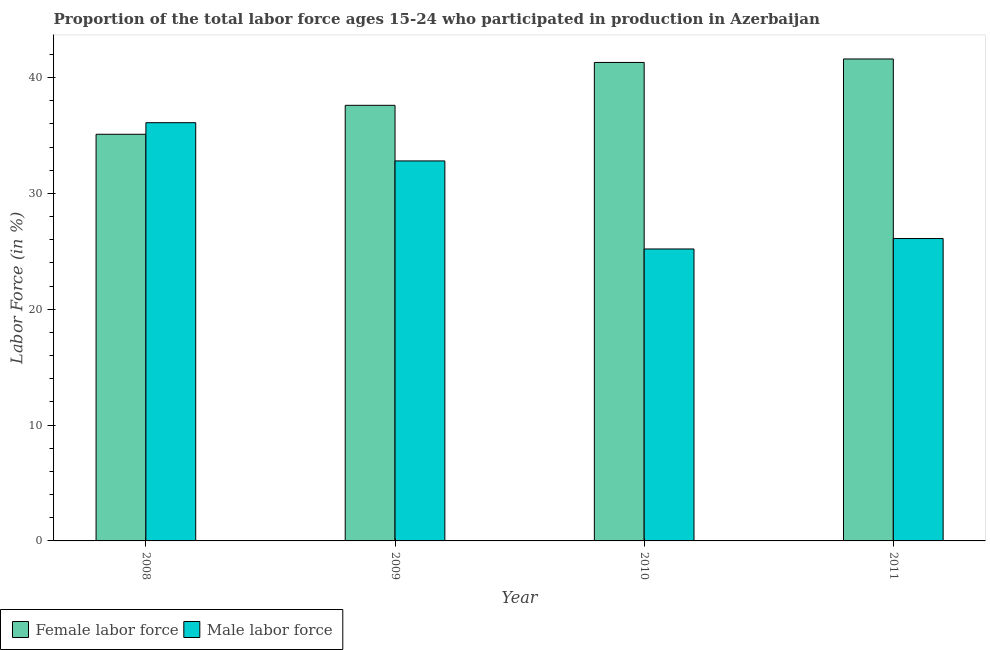Are the number of bars on each tick of the X-axis equal?
Your answer should be very brief. Yes. What is the label of the 4th group of bars from the left?
Ensure brevity in your answer.  2011. In how many cases, is the number of bars for a given year not equal to the number of legend labels?
Make the answer very short. 0. What is the percentage of male labour force in 2009?
Your answer should be compact. 32.8. Across all years, what is the maximum percentage of female labor force?
Give a very brief answer. 41.6. Across all years, what is the minimum percentage of female labor force?
Make the answer very short. 35.1. In which year was the percentage of male labour force maximum?
Keep it short and to the point. 2008. What is the total percentage of female labor force in the graph?
Your answer should be compact. 155.6. What is the difference between the percentage of female labor force in 2009 and that in 2011?
Keep it short and to the point. -4. What is the difference between the percentage of female labor force in 2010 and the percentage of male labour force in 2009?
Ensure brevity in your answer.  3.7. What is the average percentage of male labour force per year?
Your response must be concise. 30.05. In the year 2008, what is the difference between the percentage of male labour force and percentage of female labor force?
Offer a very short reply. 0. In how many years, is the percentage of female labor force greater than 12 %?
Provide a succinct answer. 4. What is the ratio of the percentage of male labour force in 2008 to that in 2011?
Your response must be concise. 1.38. What is the difference between the highest and the second highest percentage of female labor force?
Provide a succinct answer. 0.3. What is the difference between the highest and the lowest percentage of male labour force?
Keep it short and to the point. 10.9. What does the 1st bar from the left in 2008 represents?
Your answer should be compact. Female labor force. What does the 1st bar from the right in 2011 represents?
Provide a succinct answer. Male labor force. How many years are there in the graph?
Provide a succinct answer. 4. What is the difference between two consecutive major ticks on the Y-axis?
Your response must be concise. 10. Are the values on the major ticks of Y-axis written in scientific E-notation?
Offer a terse response. No. Does the graph contain any zero values?
Offer a very short reply. No. Where does the legend appear in the graph?
Make the answer very short. Bottom left. How are the legend labels stacked?
Provide a short and direct response. Horizontal. What is the title of the graph?
Give a very brief answer. Proportion of the total labor force ages 15-24 who participated in production in Azerbaijan. What is the label or title of the X-axis?
Ensure brevity in your answer.  Year. What is the Labor Force (in %) in Female labor force in 2008?
Offer a very short reply. 35.1. What is the Labor Force (in %) of Male labor force in 2008?
Ensure brevity in your answer.  36.1. What is the Labor Force (in %) in Female labor force in 2009?
Provide a short and direct response. 37.6. What is the Labor Force (in %) in Male labor force in 2009?
Offer a very short reply. 32.8. What is the Labor Force (in %) of Female labor force in 2010?
Your answer should be compact. 41.3. What is the Labor Force (in %) in Male labor force in 2010?
Provide a short and direct response. 25.2. What is the Labor Force (in %) in Female labor force in 2011?
Make the answer very short. 41.6. What is the Labor Force (in %) of Male labor force in 2011?
Keep it short and to the point. 26.1. Across all years, what is the maximum Labor Force (in %) of Female labor force?
Give a very brief answer. 41.6. Across all years, what is the maximum Labor Force (in %) of Male labor force?
Your answer should be compact. 36.1. Across all years, what is the minimum Labor Force (in %) of Female labor force?
Your response must be concise. 35.1. Across all years, what is the minimum Labor Force (in %) of Male labor force?
Provide a short and direct response. 25.2. What is the total Labor Force (in %) of Female labor force in the graph?
Offer a very short reply. 155.6. What is the total Labor Force (in %) of Male labor force in the graph?
Give a very brief answer. 120.2. What is the difference between the Labor Force (in %) of Female labor force in 2008 and that in 2009?
Your answer should be compact. -2.5. What is the difference between the Labor Force (in %) in Male labor force in 2008 and that in 2009?
Offer a terse response. 3.3. What is the difference between the Labor Force (in %) in Male labor force in 2008 and that in 2010?
Ensure brevity in your answer.  10.9. What is the difference between the Labor Force (in %) in Female labor force in 2008 and that in 2011?
Keep it short and to the point. -6.5. What is the difference between the Labor Force (in %) in Female labor force in 2009 and that in 2010?
Provide a short and direct response. -3.7. What is the difference between the Labor Force (in %) in Female labor force in 2009 and that in 2011?
Ensure brevity in your answer.  -4. What is the difference between the Labor Force (in %) in Male labor force in 2009 and that in 2011?
Ensure brevity in your answer.  6.7. What is the difference between the Labor Force (in %) of Female labor force in 2010 and that in 2011?
Your answer should be very brief. -0.3. What is the difference between the Labor Force (in %) in Female labor force in 2008 and the Labor Force (in %) in Male labor force in 2009?
Offer a terse response. 2.3. What is the difference between the Labor Force (in %) in Female labor force in 2009 and the Labor Force (in %) in Male labor force in 2010?
Your answer should be very brief. 12.4. What is the difference between the Labor Force (in %) of Female labor force in 2009 and the Labor Force (in %) of Male labor force in 2011?
Offer a terse response. 11.5. What is the average Labor Force (in %) in Female labor force per year?
Provide a short and direct response. 38.9. What is the average Labor Force (in %) in Male labor force per year?
Your response must be concise. 30.05. In the year 2008, what is the difference between the Labor Force (in %) in Female labor force and Labor Force (in %) in Male labor force?
Offer a terse response. -1. In the year 2011, what is the difference between the Labor Force (in %) of Female labor force and Labor Force (in %) of Male labor force?
Offer a very short reply. 15.5. What is the ratio of the Labor Force (in %) in Female labor force in 2008 to that in 2009?
Offer a very short reply. 0.93. What is the ratio of the Labor Force (in %) of Male labor force in 2008 to that in 2009?
Your response must be concise. 1.1. What is the ratio of the Labor Force (in %) of Female labor force in 2008 to that in 2010?
Your answer should be compact. 0.85. What is the ratio of the Labor Force (in %) of Male labor force in 2008 to that in 2010?
Your answer should be very brief. 1.43. What is the ratio of the Labor Force (in %) in Female labor force in 2008 to that in 2011?
Your answer should be very brief. 0.84. What is the ratio of the Labor Force (in %) of Male labor force in 2008 to that in 2011?
Provide a succinct answer. 1.38. What is the ratio of the Labor Force (in %) of Female labor force in 2009 to that in 2010?
Offer a very short reply. 0.91. What is the ratio of the Labor Force (in %) in Male labor force in 2009 to that in 2010?
Ensure brevity in your answer.  1.3. What is the ratio of the Labor Force (in %) of Female labor force in 2009 to that in 2011?
Keep it short and to the point. 0.9. What is the ratio of the Labor Force (in %) of Male labor force in 2009 to that in 2011?
Ensure brevity in your answer.  1.26. What is the ratio of the Labor Force (in %) of Male labor force in 2010 to that in 2011?
Offer a very short reply. 0.97. What is the difference between the highest and the lowest Labor Force (in %) in Male labor force?
Your answer should be very brief. 10.9. 